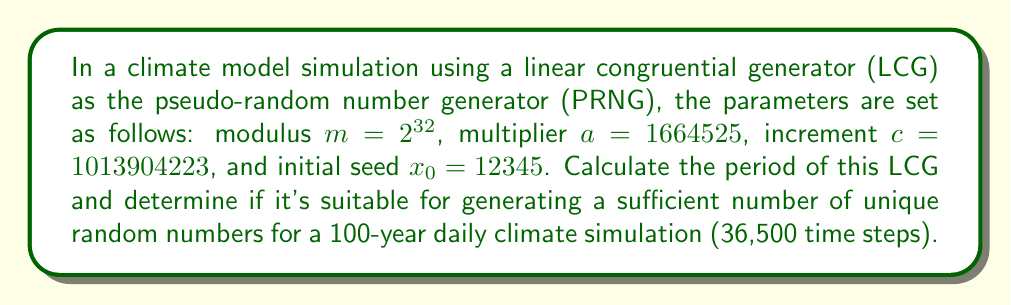Provide a solution to this math problem. 1) The period of an LCG is at most $m$, and reaches this maximum when:
   a) $c$ and $m$ are relatively prime
   b) $a - 1$ is divisible by all prime factors of $m$
   c) $a - 1$ is divisible by 4 if $m$ is divisible by 4

2) For our LCG:
   $m = 2^{32}$
   $a = 1664525$
   $c = 1013904223$

3) Check condition (a):
   $gcd(c, m) = gcd(1013904223, 2^{32}) = 1$
   So, $c$ and $m$ are relatively prime.

4) Check condition (b):
   $m = 2^{32}$, so the only prime factor is 2.
   $a - 1 = 1664525 - 1 = 1664524 = 2 \times 832262$
   1664524 is even, so it's divisible by 2.

5) Check condition (c):
   $m = 2^{32}$ is divisible by 4.
   $a - 1 = 1664524 = 4 \times 416131$
   So, $a - 1$ is divisible by 4.

6) All conditions are met, so the period is maximal: $2^{32} = 4,294,967,296$

7) For a 100-year daily simulation:
   Required unique numbers = 36,500
   $4,294,967,296 > 36,500$

Therefore, this LCG has a sufficient period for the climate simulation.
Answer: Period: $2^{32} = 4,294,967,296$; Suitable for 100-year daily simulation. 